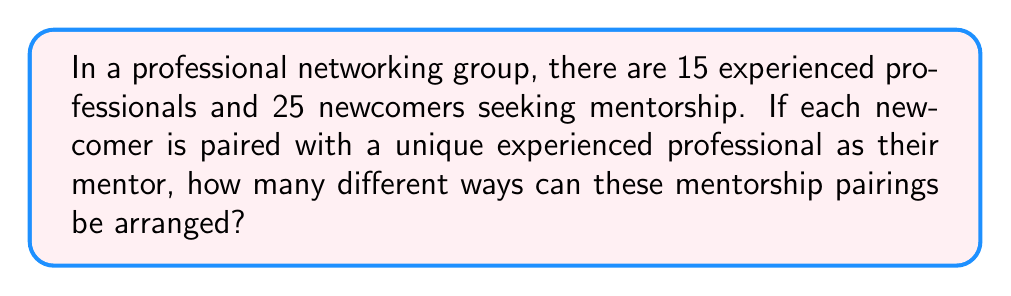Can you solve this math problem? Let's approach this step-by-step:

1) This is a permutation problem. We need to select mentors for each of the newcomers.

2) For the first newcomer, there are 15 choices of mentors.

3) For the second newcomer, there are 14 choices left, as one mentor has already been paired.

4) This continues until we've paired all 15 mentors (as there are more newcomers than mentors).

5) This scenario can be represented mathematically as:

   $$15 \times 14 \times 13 \times 12 \times 11 \times 10 \times 9 \times 8 \times 7 \times 6 \times 5 \times 4 \times 3 \times 2 \times 1$$

6) This is equivalent to the permutation formula:

   $$P(15,15) = \frac{15!}{(15-15)!} = 15!$$

7) Calculate 15!:
   
   $$15! = 1,307,674,368,000$$

Therefore, there are 1,307,674,368,000 different ways to arrange these mentorship pairings.
Answer: 1,307,674,368,000 